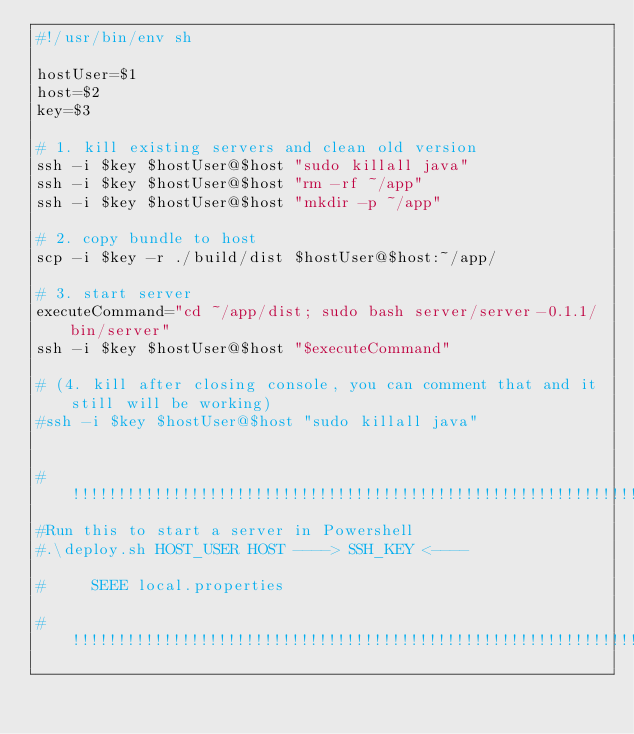Convert code to text. <code><loc_0><loc_0><loc_500><loc_500><_Bash_>#!/usr/bin/env sh

hostUser=$1
host=$2
key=$3

# 1. kill existing servers and clean old version
ssh -i $key $hostUser@$host "sudo killall java"
ssh -i $key $hostUser@$host "rm -rf ~/app"
ssh -i $key $hostUser@$host "mkdir -p ~/app"

# 2. copy bundle to host
scp -i $key -r ./build/dist $hostUser@$host:~/app/

# 3. start server
executeCommand="cd ~/app/dist; sudo bash server/server-0.1.1/bin/server"
ssh -i $key $hostUser@$host "$executeCommand"

# (4. kill after closing console, you can comment that and it still will be working)
#ssh -i $key $hostUser@$host "sudo killall java"


#!!!!!!!!!!!!!!!!!!!!!!!!!!!!!!!!!!!!!!!!!!!!!!!!!!!!!!!!!!!!!!!!!!!!!
#Run this to start a server in Powershell
#.\deploy.sh HOST_USER HOST ----> SSH_KEY <----

#     SEEE local.properties

#!!!!!!!!!!!!!!!!!!!!!!!!!!!!!!!!!!!!!!!!!!!!!!!!!!!!!!!!!!!!!!!!!!!!!</code> 